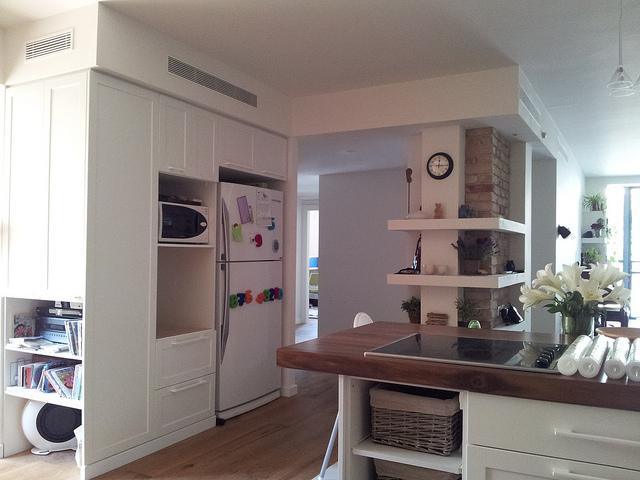Are the walls and cabinets the same color?
Give a very brief answer. Yes. What room of the house is this?
Answer briefly. Kitchen. Where is the clock?
Give a very brief answer. Wall. 